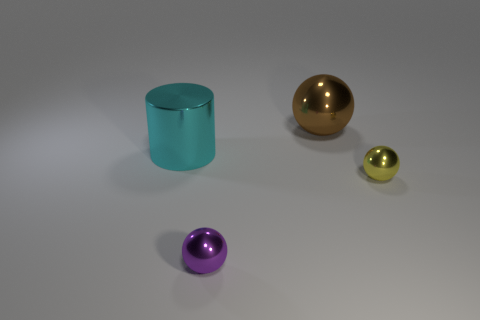How many shiny cylinders are on the right side of the yellow metallic thing?
Give a very brief answer. 0. What is the material of the thing that is behind the purple shiny ball and left of the big sphere?
Give a very brief answer. Metal. How many cubes are either purple things or brown things?
Your response must be concise. 0. There is a purple object that is the same shape as the brown metallic object; what is it made of?
Provide a succinct answer. Metal. There is a yellow object that is the same material as the big brown thing; what is its size?
Offer a terse response. Small. There is a brown object that is left of the tiny yellow thing; is it the same shape as the tiny thing that is right of the brown metal ball?
Give a very brief answer. Yes. There is another tiny ball that is the same material as the small yellow sphere; what is its color?
Offer a terse response. Purple. There is a metal thing that is behind the large cyan object; is its size the same as the metallic ball that is in front of the yellow shiny sphere?
Offer a very short reply. No. There is a metal thing that is both right of the purple sphere and in front of the brown ball; what shape is it?
Make the answer very short. Sphere. Is there a small gray cylinder that has the same material as the large sphere?
Your answer should be compact. No. 